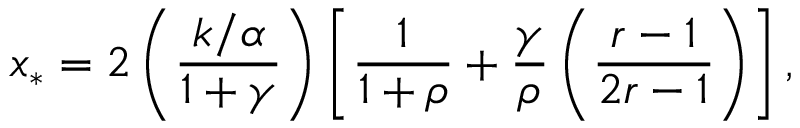<formula> <loc_0><loc_0><loc_500><loc_500>x _ { * } = 2 \left ( \frac { k / \alpha } { 1 + \gamma } \right ) \left [ \frac { 1 } { 1 + \rho } + \frac { \gamma } { \rho } \left ( \frac { r - 1 } { 2 r - 1 } \right ) \right ] ,</formula> 